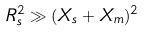<formula> <loc_0><loc_0><loc_500><loc_500>R _ { s } ^ { 2 } \gg ( X _ { s } + X _ { m } ) ^ { 2 }</formula> 